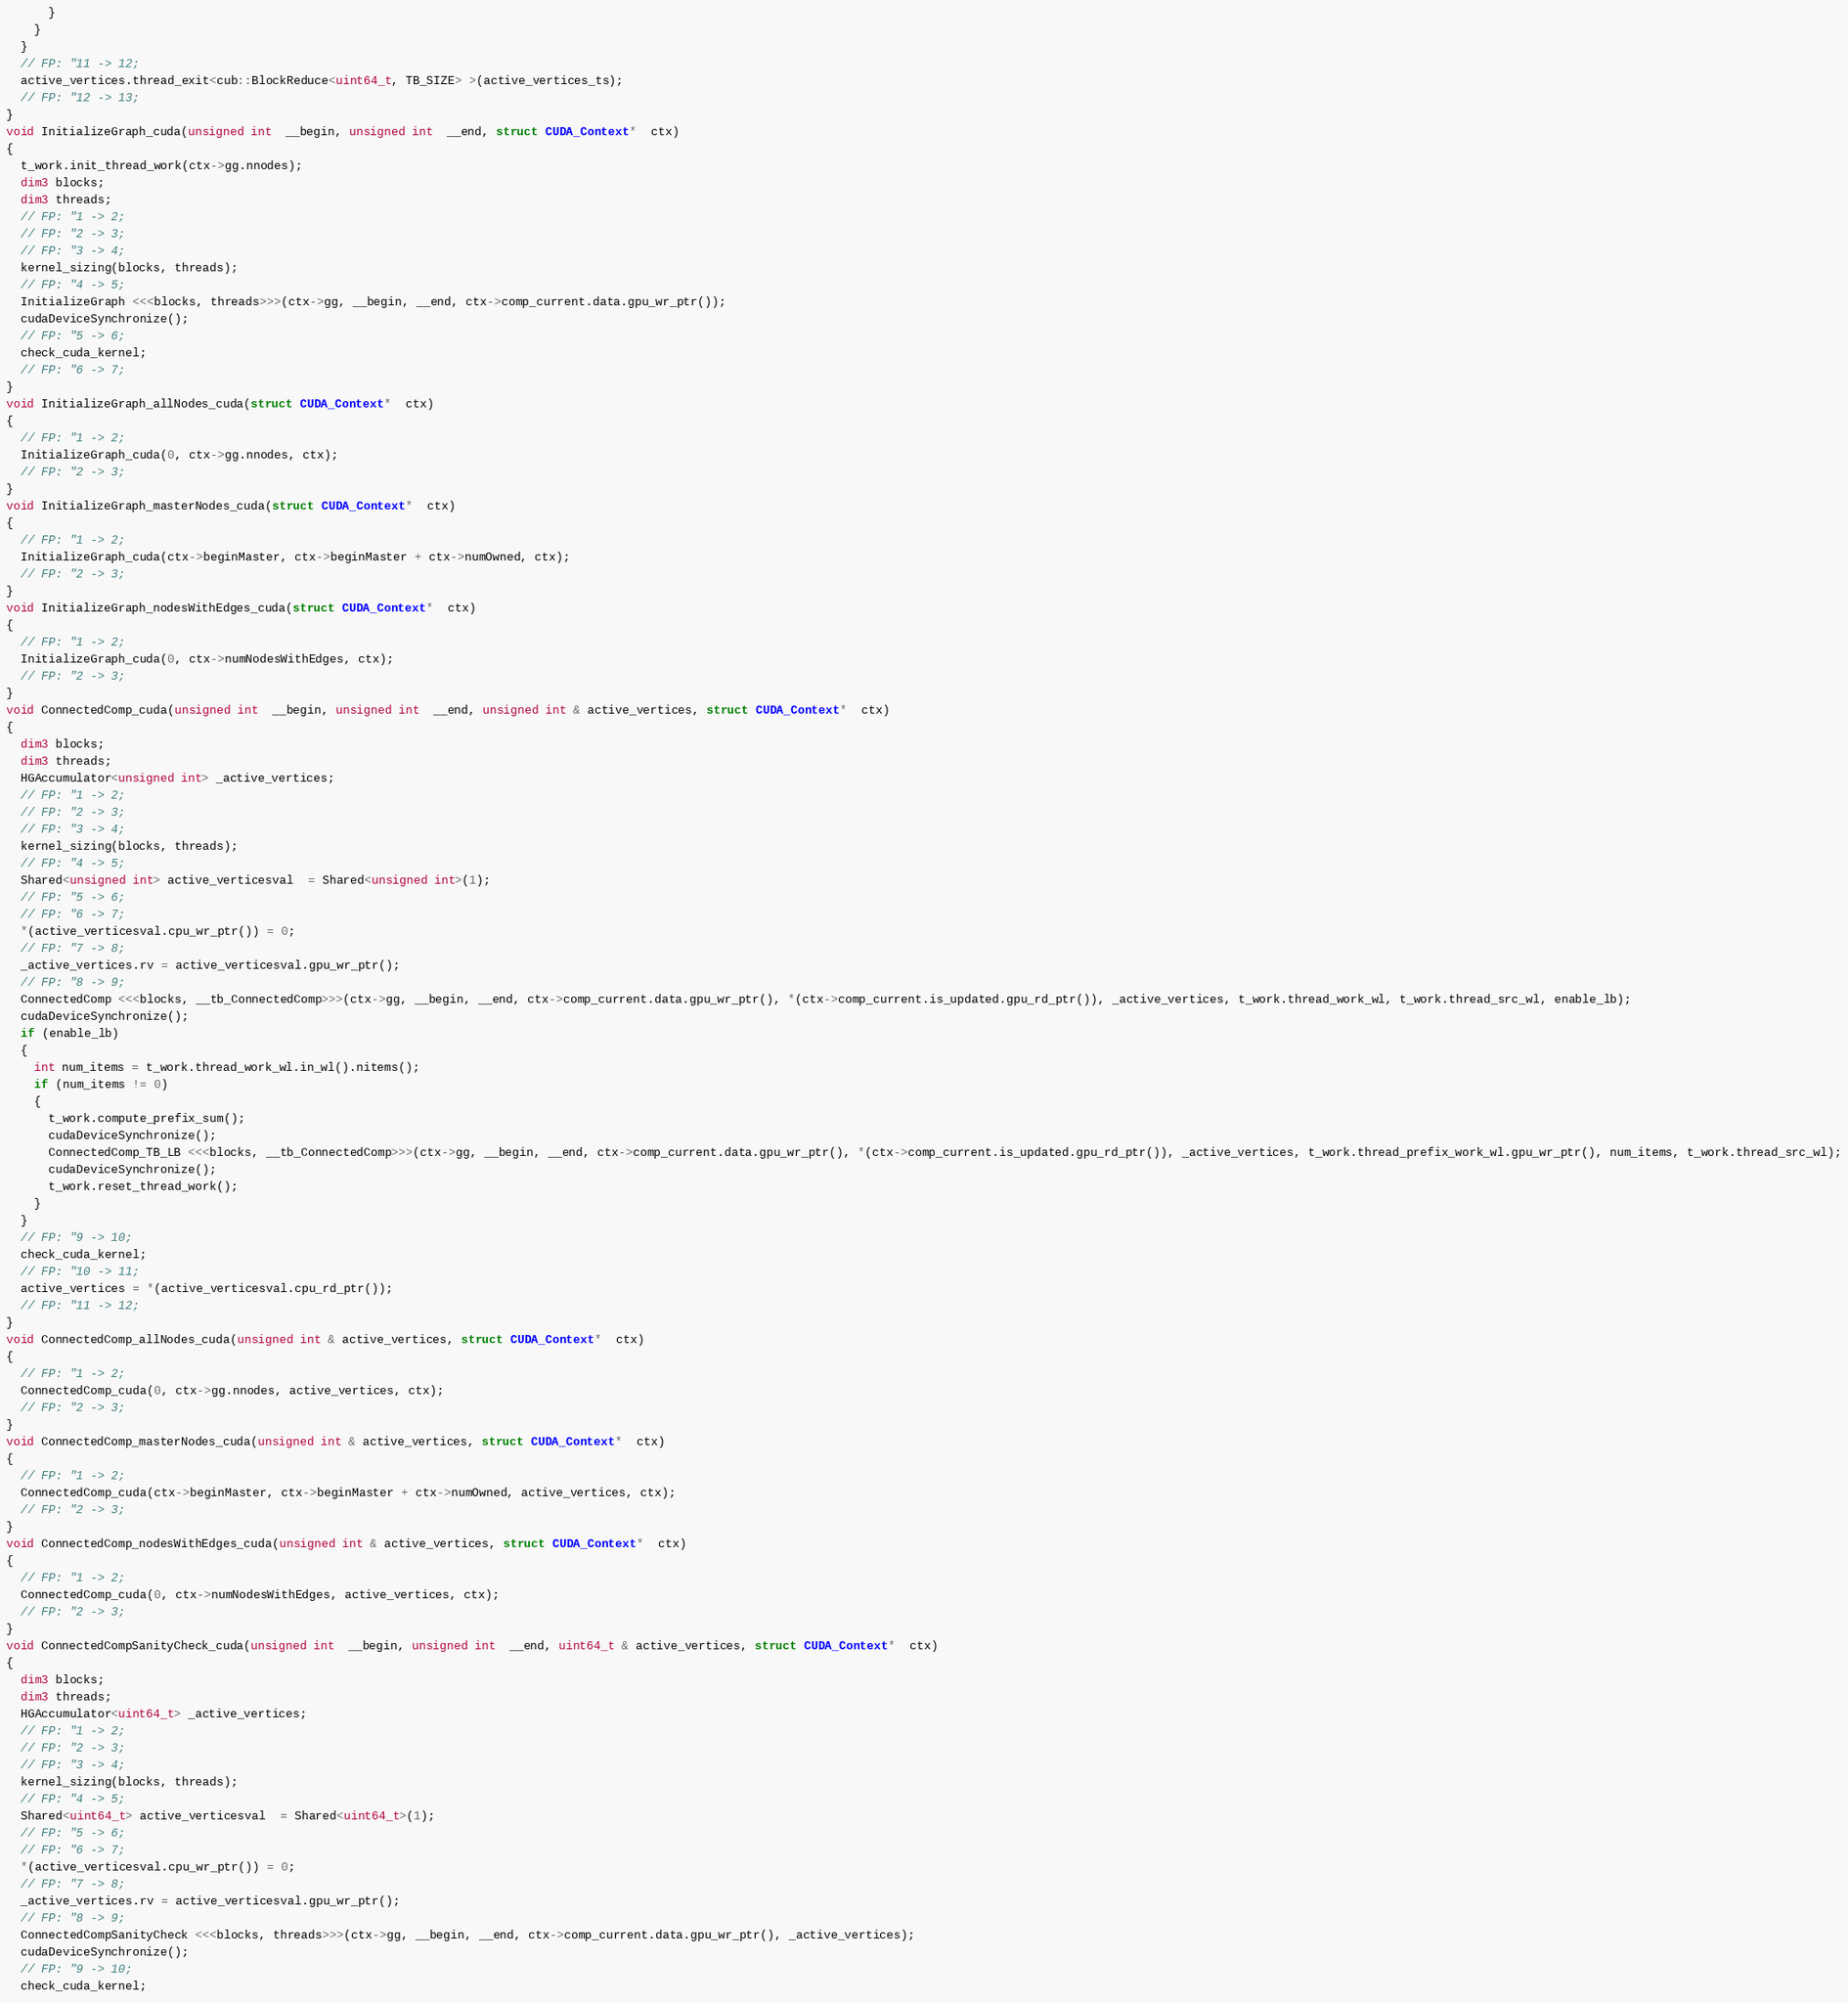Convert code to text. <code><loc_0><loc_0><loc_500><loc_500><_Cuda_>      }
    }
  }
  // FP: "11 -> 12;
  active_vertices.thread_exit<cub::BlockReduce<uint64_t, TB_SIZE> >(active_vertices_ts);
  // FP: "12 -> 13;
}
void InitializeGraph_cuda(unsigned int  __begin, unsigned int  __end, struct CUDA_Context*  ctx)
{
  t_work.init_thread_work(ctx->gg.nnodes);
  dim3 blocks;
  dim3 threads;
  // FP: "1 -> 2;
  // FP: "2 -> 3;
  // FP: "3 -> 4;
  kernel_sizing(blocks, threads);
  // FP: "4 -> 5;
  InitializeGraph <<<blocks, threads>>>(ctx->gg, __begin, __end, ctx->comp_current.data.gpu_wr_ptr());
  cudaDeviceSynchronize();
  // FP: "5 -> 6;
  check_cuda_kernel;
  // FP: "6 -> 7;
}
void InitializeGraph_allNodes_cuda(struct CUDA_Context*  ctx)
{
  // FP: "1 -> 2;
  InitializeGraph_cuda(0, ctx->gg.nnodes, ctx);
  // FP: "2 -> 3;
}
void InitializeGraph_masterNodes_cuda(struct CUDA_Context*  ctx)
{
  // FP: "1 -> 2;
  InitializeGraph_cuda(ctx->beginMaster, ctx->beginMaster + ctx->numOwned, ctx);
  // FP: "2 -> 3;
}
void InitializeGraph_nodesWithEdges_cuda(struct CUDA_Context*  ctx)
{
  // FP: "1 -> 2;
  InitializeGraph_cuda(0, ctx->numNodesWithEdges, ctx);
  // FP: "2 -> 3;
}
void ConnectedComp_cuda(unsigned int  __begin, unsigned int  __end, unsigned int & active_vertices, struct CUDA_Context*  ctx)
{
  dim3 blocks;
  dim3 threads;
  HGAccumulator<unsigned int> _active_vertices;
  // FP: "1 -> 2;
  // FP: "2 -> 3;
  // FP: "3 -> 4;
  kernel_sizing(blocks, threads);
  // FP: "4 -> 5;
  Shared<unsigned int> active_verticesval  = Shared<unsigned int>(1);
  // FP: "5 -> 6;
  // FP: "6 -> 7;
  *(active_verticesval.cpu_wr_ptr()) = 0;
  // FP: "7 -> 8;
  _active_vertices.rv = active_verticesval.gpu_wr_ptr();
  // FP: "8 -> 9;
  ConnectedComp <<<blocks, __tb_ConnectedComp>>>(ctx->gg, __begin, __end, ctx->comp_current.data.gpu_wr_ptr(), *(ctx->comp_current.is_updated.gpu_rd_ptr()), _active_vertices, t_work.thread_work_wl, t_work.thread_src_wl, enable_lb);
  cudaDeviceSynchronize();
  if (enable_lb)
  {
    int num_items = t_work.thread_work_wl.in_wl().nitems();
    if (num_items != 0)
    {
      t_work.compute_prefix_sum();
      cudaDeviceSynchronize();
      ConnectedComp_TB_LB <<<blocks, __tb_ConnectedComp>>>(ctx->gg, __begin, __end, ctx->comp_current.data.gpu_wr_ptr(), *(ctx->comp_current.is_updated.gpu_rd_ptr()), _active_vertices, t_work.thread_prefix_work_wl.gpu_wr_ptr(), num_items, t_work.thread_src_wl);
      cudaDeviceSynchronize();
      t_work.reset_thread_work();
    }
  }
  // FP: "9 -> 10;
  check_cuda_kernel;
  // FP: "10 -> 11;
  active_vertices = *(active_verticesval.cpu_rd_ptr());
  // FP: "11 -> 12;
}
void ConnectedComp_allNodes_cuda(unsigned int & active_vertices, struct CUDA_Context*  ctx)
{
  // FP: "1 -> 2;
  ConnectedComp_cuda(0, ctx->gg.nnodes, active_vertices, ctx);
  // FP: "2 -> 3;
}
void ConnectedComp_masterNodes_cuda(unsigned int & active_vertices, struct CUDA_Context*  ctx)
{
  // FP: "1 -> 2;
  ConnectedComp_cuda(ctx->beginMaster, ctx->beginMaster + ctx->numOwned, active_vertices, ctx);
  // FP: "2 -> 3;
}
void ConnectedComp_nodesWithEdges_cuda(unsigned int & active_vertices, struct CUDA_Context*  ctx)
{
  // FP: "1 -> 2;
  ConnectedComp_cuda(0, ctx->numNodesWithEdges, active_vertices, ctx);
  // FP: "2 -> 3;
}
void ConnectedCompSanityCheck_cuda(unsigned int  __begin, unsigned int  __end, uint64_t & active_vertices, struct CUDA_Context*  ctx)
{
  dim3 blocks;
  dim3 threads;
  HGAccumulator<uint64_t> _active_vertices;
  // FP: "1 -> 2;
  // FP: "2 -> 3;
  // FP: "3 -> 4;
  kernel_sizing(blocks, threads);
  // FP: "4 -> 5;
  Shared<uint64_t> active_verticesval  = Shared<uint64_t>(1);
  // FP: "5 -> 6;
  // FP: "6 -> 7;
  *(active_verticesval.cpu_wr_ptr()) = 0;
  // FP: "7 -> 8;
  _active_vertices.rv = active_verticesval.gpu_wr_ptr();
  // FP: "8 -> 9;
  ConnectedCompSanityCheck <<<blocks, threads>>>(ctx->gg, __begin, __end, ctx->comp_current.data.gpu_wr_ptr(), _active_vertices);
  cudaDeviceSynchronize();
  // FP: "9 -> 10;
  check_cuda_kernel;</code> 